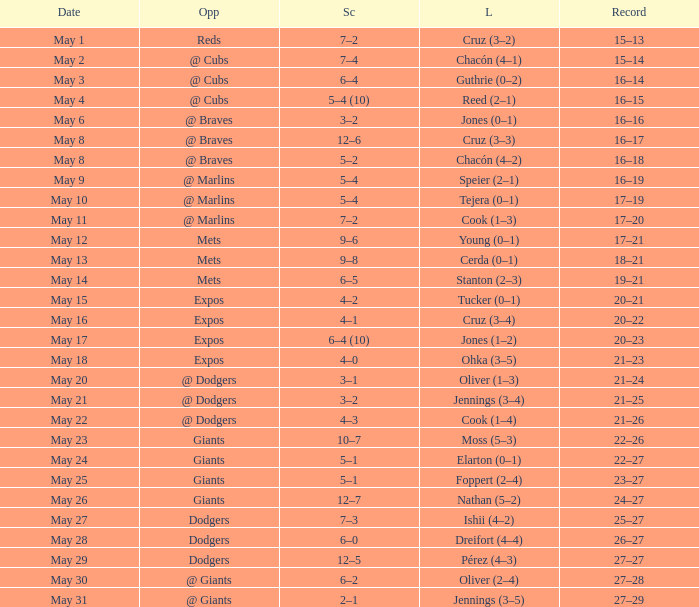Tell me who was the opponent on May 6 @ Braves. 